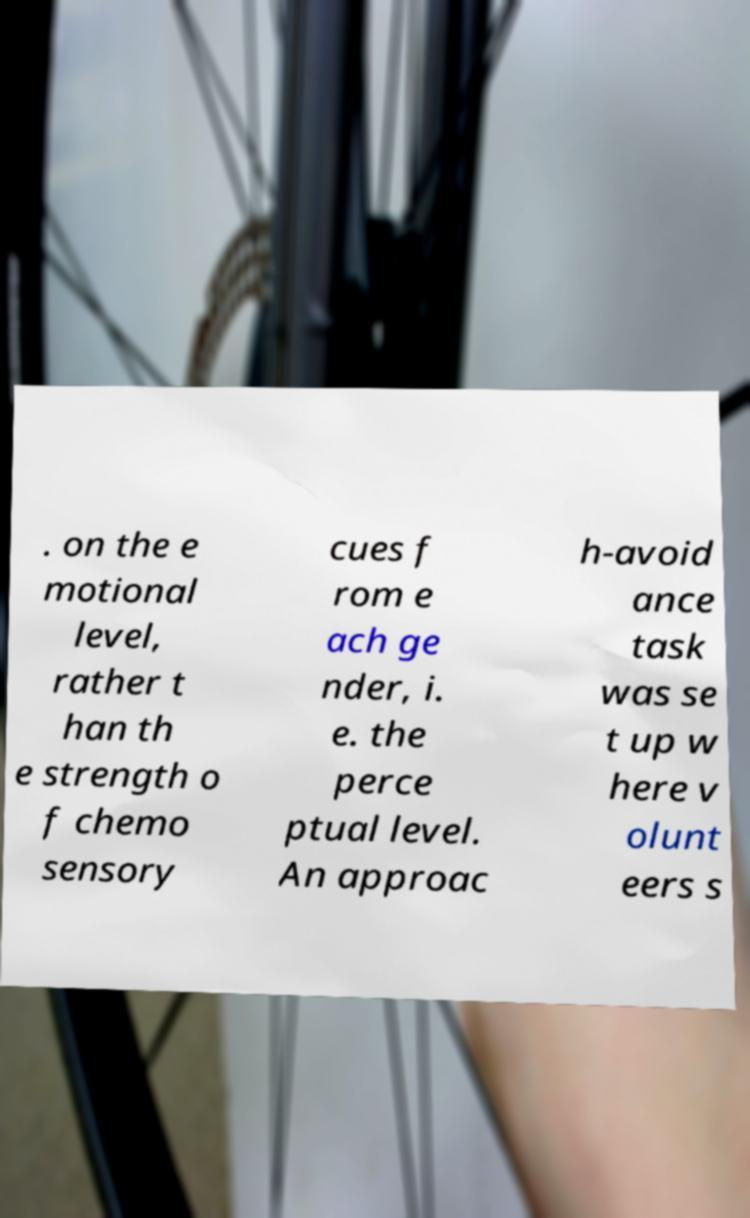I need the written content from this picture converted into text. Can you do that? . on the e motional level, rather t han th e strength o f chemo sensory cues f rom e ach ge nder, i. e. the perce ptual level. An approac h-avoid ance task was se t up w here v olunt eers s 